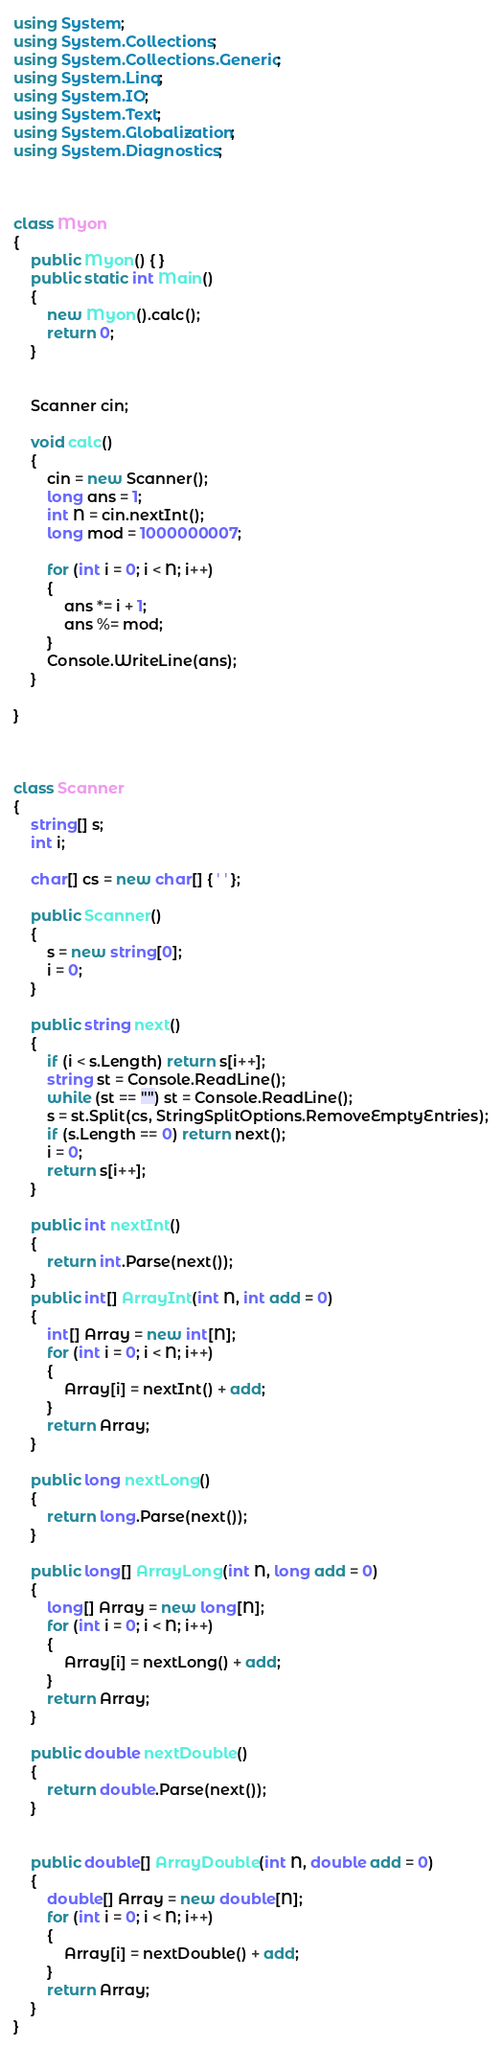Convert code to text. <code><loc_0><loc_0><loc_500><loc_500><_C#_>using System;
using System.Collections;
using System.Collections.Generic;
using System.Linq;
using System.IO;
using System.Text;
using System.Globalization;
using System.Diagnostics;



class Myon
{
    public Myon() { }
    public static int Main()
    {
        new Myon().calc();
        return 0;
    }


    Scanner cin;

    void calc()
    {
        cin = new Scanner();
        long ans = 1;
        int N = cin.nextInt();
        long mod = 1000000007;

        for (int i = 0; i < N; i++)
        {
            ans *= i + 1;
            ans %= mod;
        }
        Console.WriteLine(ans);
    }

}



class Scanner
{
    string[] s;
    int i;

    char[] cs = new char[] { ' ' };

    public Scanner()
    {
        s = new string[0];
        i = 0;
    }

    public string next()
    {
        if (i < s.Length) return s[i++];
        string st = Console.ReadLine();
        while (st == "") st = Console.ReadLine();
        s = st.Split(cs, StringSplitOptions.RemoveEmptyEntries);
        if (s.Length == 0) return next();
        i = 0;
        return s[i++];
    }

    public int nextInt()
    {
        return int.Parse(next());
    }
    public int[] ArrayInt(int N, int add = 0)
    {
        int[] Array = new int[N];
        for (int i = 0; i < N; i++)
        {
            Array[i] = nextInt() + add;
        }
        return Array;
    }

    public long nextLong()
    {
        return long.Parse(next());
    }

    public long[] ArrayLong(int N, long add = 0)
    {
        long[] Array = new long[N];
        for (int i = 0; i < N; i++)
        {
            Array[i] = nextLong() + add;
        }
        return Array;
    }

    public double nextDouble()
    {
        return double.Parse(next());
    }


    public double[] ArrayDouble(int N, double add = 0)
    {
        double[] Array = new double[N];
        for (int i = 0; i < N; i++)
        {
            Array[i] = nextDouble() + add;
        }
        return Array;
    }
}
</code> 